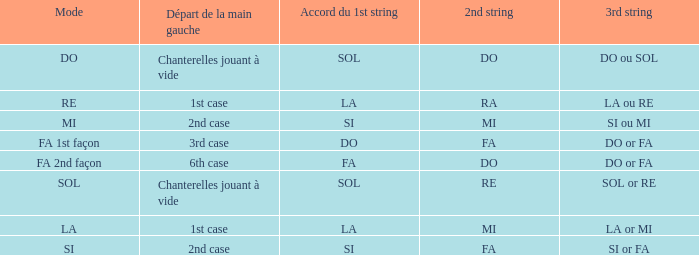For the 2nd string of do and an accord du 1st string of fa, what is the beginning of the left hand? 6th case. 